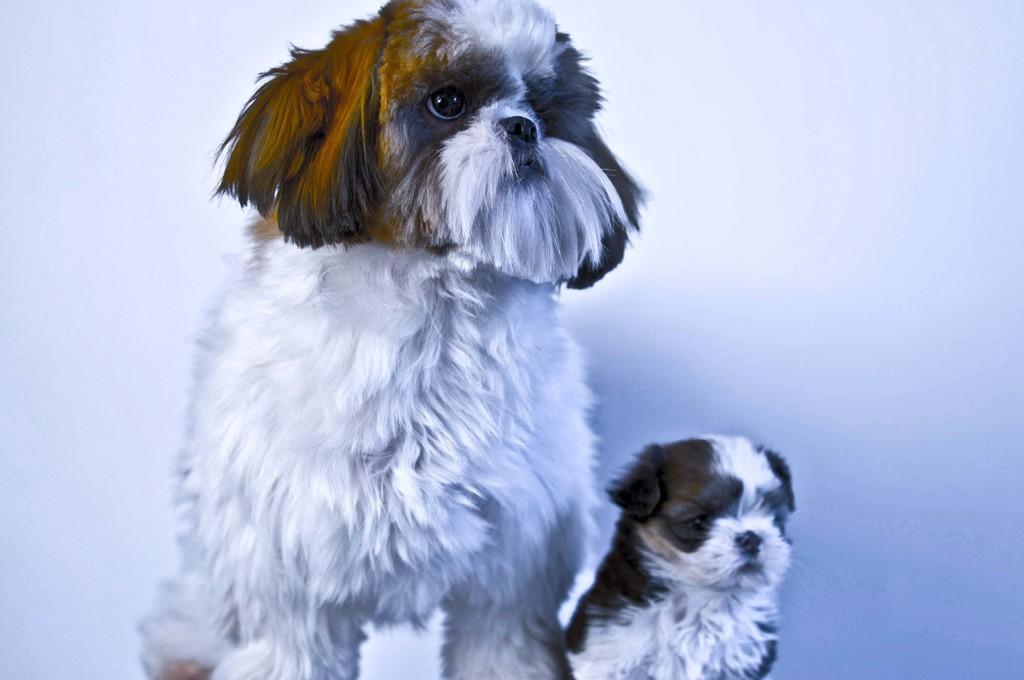Describe this image in one or two sentences. In this image we can see dogs. 